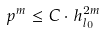Convert formula to latex. <formula><loc_0><loc_0><loc_500><loc_500>p ^ { m } \leq C \cdot h ^ { 2 m } _ { l _ { 0 } }</formula> 